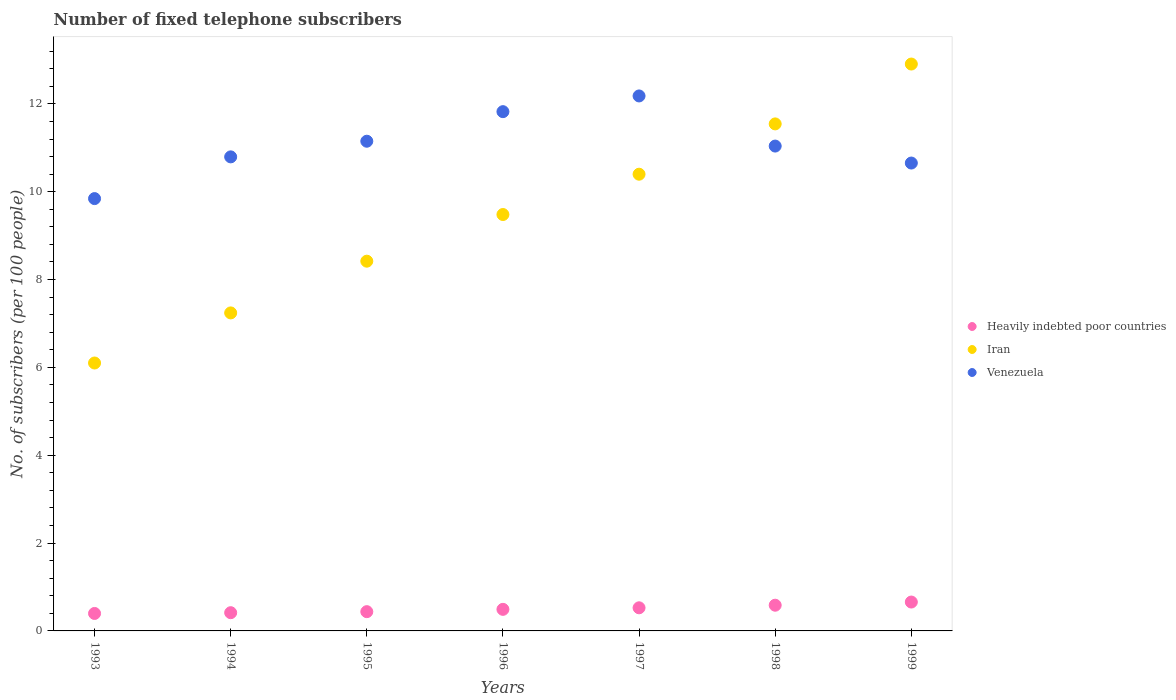Is the number of dotlines equal to the number of legend labels?
Make the answer very short. Yes. What is the number of fixed telephone subscribers in Heavily indebted poor countries in 1995?
Give a very brief answer. 0.44. Across all years, what is the maximum number of fixed telephone subscribers in Heavily indebted poor countries?
Offer a terse response. 0.66. Across all years, what is the minimum number of fixed telephone subscribers in Iran?
Provide a succinct answer. 6.1. In which year was the number of fixed telephone subscribers in Venezuela minimum?
Offer a very short reply. 1993. What is the total number of fixed telephone subscribers in Venezuela in the graph?
Your answer should be compact. 77.48. What is the difference between the number of fixed telephone subscribers in Venezuela in 1994 and that in 1997?
Provide a succinct answer. -1.39. What is the difference between the number of fixed telephone subscribers in Venezuela in 1995 and the number of fixed telephone subscribers in Heavily indebted poor countries in 1999?
Your answer should be compact. 10.49. What is the average number of fixed telephone subscribers in Iran per year?
Provide a short and direct response. 9.44. In the year 1995, what is the difference between the number of fixed telephone subscribers in Iran and number of fixed telephone subscribers in Venezuela?
Your answer should be very brief. -2.73. In how many years, is the number of fixed telephone subscribers in Iran greater than 9.6?
Provide a succinct answer. 3. What is the ratio of the number of fixed telephone subscribers in Venezuela in 1996 to that in 1997?
Provide a short and direct response. 0.97. Is the difference between the number of fixed telephone subscribers in Iran in 1993 and 1996 greater than the difference between the number of fixed telephone subscribers in Venezuela in 1993 and 1996?
Give a very brief answer. No. What is the difference between the highest and the second highest number of fixed telephone subscribers in Heavily indebted poor countries?
Offer a very short reply. 0.07. What is the difference between the highest and the lowest number of fixed telephone subscribers in Heavily indebted poor countries?
Offer a terse response. 0.26. In how many years, is the number of fixed telephone subscribers in Heavily indebted poor countries greater than the average number of fixed telephone subscribers in Heavily indebted poor countries taken over all years?
Offer a very short reply. 3. Is it the case that in every year, the sum of the number of fixed telephone subscribers in Venezuela and number of fixed telephone subscribers in Iran  is greater than the number of fixed telephone subscribers in Heavily indebted poor countries?
Keep it short and to the point. Yes. Does the number of fixed telephone subscribers in Heavily indebted poor countries monotonically increase over the years?
Offer a very short reply. Yes. Is the number of fixed telephone subscribers in Heavily indebted poor countries strictly greater than the number of fixed telephone subscribers in Iran over the years?
Ensure brevity in your answer.  No. Is the number of fixed telephone subscribers in Heavily indebted poor countries strictly less than the number of fixed telephone subscribers in Venezuela over the years?
Keep it short and to the point. Yes. How many dotlines are there?
Make the answer very short. 3. How many years are there in the graph?
Ensure brevity in your answer.  7. Are the values on the major ticks of Y-axis written in scientific E-notation?
Ensure brevity in your answer.  No. How many legend labels are there?
Ensure brevity in your answer.  3. How are the legend labels stacked?
Offer a very short reply. Vertical. What is the title of the graph?
Make the answer very short. Number of fixed telephone subscribers. What is the label or title of the X-axis?
Your answer should be compact. Years. What is the label or title of the Y-axis?
Your answer should be very brief. No. of subscribers (per 100 people). What is the No. of subscribers (per 100 people) of Heavily indebted poor countries in 1993?
Offer a very short reply. 0.4. What is the No. of subscribers (per 100 people) of Iran in 1993?
Your answer should be compact. 6.1. What is the No. of subscribers (per 100 people) in Venezuela in 1993?
Your response must be concise. 9.84. What is the No. of subscribers (per 100 people) in Heavily indebted poor countries in 1994?
Make the answer very short. 0.41. What is the No. of subscribers (per 100 people) in Iran in 1994?
Your answer should be very brief. 7.24. What is the No. of subscribers (per 100 people) of Venezuela in 1994?
Your response must be concise. 10.79. What is the No. of subscribers (per 100 people) of Heavily indebted poor countries in 1995?
Offer a very short reply. 0.44. What is the No. of subscribers (per 100 people) of Iran in 1995?
Ensure brevity in your answer.  8.42. What is the No. of subscribers (per 100 people) in Venezuela in 1995?
Offer a very short reply. 11.15. What is the No. of subscribers (per 100 people) of Heavily indebted poor countries in 1996?
Your response must be concise. 0.49. What is the No. of subscribers (per 100 people) in Iran in 1996?
Make the answer very short. 9.48. What is the No. of subscribers (per 100 people) of Venezuela in 1996?
Provide a short and direct response. 11.82. What is the No. of subscribers (per 100 people) in Heavily indebted poor countries in 1997?
Make the answer very short. 0.53. What is the No. of subscribers (per 100 people) of Iran in 1997?
Give a very brief answer. 10.4. What is the No. of subscribers (per 100 people) of Venezuela in 1997?
Offer a very short reply. 12.18. What is the No. of subscribers (per 100 people) in Heavily indebted poor countries in 1998?
Your response must be concise. 0.59. What is the No. of subscribers (per 100 people) in Iran in 1998?
Provide a short and direct response. 11.54. What is the No. of subscribers (per 100 people) in Venezuela in 1998?
Provide a short and direct response. 11.04. What is the No. of subscribers (per 100 people) of Heavily indebted poor countries in 1999?
Keep it short and to the point. 0.66. What is the No. of subscribers (per 100 people) in Iran in 1999?
Keep it short and to the point. 12.91. What is the No. of subscribers (per 100 people) in Venezuela in 1999?
Provide a short and direct response. 10.65. Across all years, what is the maximum No. of subscribers (per 100 people) of Heavily indebted poor countries?
Give a very brief answer. 0.66. Across all years, what is the maximum No. of subscribers (per 100 people) of Iran?
Your answer should be very brief. 12.91. Across all years, what is the maximum No. of subscribers (per 100 people) of Venezuela?
Give a very brief answer. 12.18. Across all years, what is the minimum No. of subscribers (per 100 people) of Heavily indebted poor countries?
Provide a short and direct response. 0.4. Across all years, what is the minimum No. of subscribers (per 100 people) in Iran?
Offer a terse response. 6.1. Across all years, what is the minimum No. of subscribers (per 100 people) in Venezuela?
Offer a terse response. 9.84. What is the total No. of subscribers (per 100 people) of Heavily indebted poor countries in the graph?
Provide a succinct answer. 3.51. What is the total No. of subscribers (per 100 people) in Iran in the graph?
Offer a very short reply. 66.09. What is the total No. of subscribers (per 100 people) in Venezuela in the graph?
Make the answer very short. 77.48. What is the difference between the No. of subscribers (per 100 people) in Heavily indebted poor countries in 1993 and that in 1994?
Give a very brief answer. -0.02. What is the difference between the No. of subscribers (per 100 people) in Iran in 1993 and that in 1994?
Provide a short and direct response. -1.14. What is the difference between the No. of subscribers (per 100 people) of Venezuela in 1993 and that in 1994?
Provide a short and direct response. -0.95. What is the difference between the No. of subscribers (per 100 people) of Heavily indebted poor countries in 1993 and that in 1995?
Your response must be concise. -0.04. What is the difference between the No. of subscribers (per 100 people) in Iran in 1993 and that in 1995?
Give a very brief answer. -2.32. What is the difference between the No. of subscribers (per 100 people) of Venezuela in 1993 and that in 1995?
Your answer should be compact. -1.31. What is the difference between the No. of subscribers (per 100 people) in Heavily indebted poor countries in 1993 and that in 1996?
Ensure brevity in your answer.  -0.09. What is the difference between the No. of subscribers (per 100 people) of Iran in 1993 and that in 1996?
Your answer should be compact. -3.38. What is the difference between the No. of subscribers (per 100 people) in Venezuela in 1993 and that in 1996?
Your response must be concise. -1.98. What is the difference between the No. of subscribers (per 100 people) of Heavily indebted poor countries in 1993 and that in 1997?
Offer a very short reply. -0.13. What is the difference between the No. of subscribers (per 100 people) in Iran in 1993 and that in 1997?
Make the answer very short. -4.3. What is the difference between the No. of subscribers (per 100 people) in Venezuela in 1993 and that in 1997?
Offer a very short reply. -2.34. What is the difference between the No. of subscribers (per 100 people) in Heavily indebted poor countries in 1993 and that in 1998?
Your answer should be very brief. -0.19. What is the difference between the No. of subscribers (per 100 people) of Iran in 1993 and that in 1998?
Give a very brief answer. -5.44. What is the difference between the No. of subscribers (per 100 people) of Venezuela in 1993 and that in 1998?
Your answer should be compact. -1.2. What is the difference between the No. of subscribers (per 100 people) of Heavily indebted poor countries in 1993 and that in 1999?
Your response must be concise. -0.26. What is the difference between the No. of subscribers (per 100 people) of Iran in 1993 and that in 1999?
Provide a short and direct response. -6.81. What is the difference between the No. of subscribers (per 100 people) of Venezuela in 1993 and that in 1999?
Offer a very short reply. -0.81. What is the difference between the No. of subscribers (per 100 people) of Heavily indebted poor countries in 1994 and that in 1995?
Your response must be concise. -0.02. What is the difference between the No. of subscribers (per 100 people) in Iran in 1994 and that in 1995?
Provide a short and direct response. -1.18. What is the difference between the No. of subscribers (per 100 people) in Venezuela in 1994 and that in 1995?
Provide a short and direct response. -0.36. What is the difference between the No. of subscribers (per 100 people) in Heavily indebted poor countries in 1994 and that in 1996?
Your answer should be compact. -0.08. What is the difference between the No. of subscribers (per 100 people) in Iran in 1994 and that in 1996?
Provide a succinct answer. -2.24. What is the difference between the No. of subscribers (per 100 people) in Venezuela in 1994 and that in 1996?
Provide a short and direct response. -1.03. What is the difference between the No. of subscribers (per 100 people) in Heavily indebted poor countries in 1994 and that in 1997?
Provide a succinct answer. -0.11. What is the difference between the No. of subscribers (per 100 people) in Iran in 1994 and that in 1997?
Ensure brevity in your answer.  -3.16. What is the difference between the No. of subscribers (per 100 people) in Venezuela in 1994 and that in 1997?
Provide a short and direct response. -1.39. What is the difference between the No. of subscribers (per 100 people) in Heavily indebted poor countries in 1994 and that in 1998?
Provide a short and direct response. -0.17. What is the difference between the No. of subscribers (per 100 people) of Iran in 1994 and that in 1998?
Provide a short and direct response. -4.3. What is the difference between the No. of subscribers (per 100 people) of Venezuela in 1994 and that in 1998?
Offer a terse response. -0.25. What is the difference between the No. of subscribers (per 100 people) in Heavily indebted poor countries in 1994 and that in 1999?
Your response must be concise. -0.24. What is the difference between the No. of subscribers (per 100 people) of Iran in 1994 and that in 1999?
Ensure brevity in your answer.  -5.67. What is the difference between the No. of subscribers (per 100 people) in Venezuela in 1994 and that in 1999?
Make the answer very short. 0.14. What is the difference between the No. of subscribers (per 100 people) in Heavily indebted poor countries in 1995 and that in 1996?
Your answer should be very brief. -0.05. What is the difference between the No. of subscribers (per 100 people) of Iran in 1995 and that in 1996?
Your answer should be compact. -1.06. What is the difference between the No. of subscribers (per 100 people) of Venezuela in 1995 and that in 1996?
Give a very brief answer. -0.67. What is the difference between the No. of subscribers (per 100 people) of Heavily indebted poor countries in 1995 and that in 1997?
Provide a short and direct response. -0.09. What is the difference between the No. of subscribers (per 100 people) of Iran in 1995 and that in 1997?
Give a very brief answer. -1.98. What is the difference between the No. of subscribers (per 100 people) of Venezuela in 1995 and that in 1997?
Provide a succinct answer. -1.03. What is the difference between the No. of subscribers (per 100 people) of Heavily indebted poor countries in 1995 and that in 1998?
Make the answer very short. -0.15. What is the difference between the No. of subscribers (per 100 people) of Iran in 1995 and that in 1998?
Your answer should be very brief. -3.13. What is the difference between the No. of subscribers (per 100 people) of Venezuela in 1995 and that in 1998?
Ensure brevity in your answer.  0.11. What is the difference between the No. of subscribers (per 100 people) of Heavily indebted poor countries in 1995 and that in 1999?
Ensure brevity in your answer.  -0.22. What is the difference between the No. of subscribers (per 100 people) in Iran in 1995 and that in 1999?
Offer a terse response. -4.49. What is the difference between the No. of subscribers (per 100 people) in Venezuela in 1995 and that in 1999?
Ensure brevity in your answer.  0.5. What is the difference between the No. of subscribers (per 100 people) in Heavily indebted poor countries in 1996 and that in 1997?
Your response must be concise. -0.04. What is the difference between the No. of subscribers (per 100 people) of Iran in 1996 and that in 1997?
Your answer should be very brief. -0.92. What is the difference between the No. of subscribers (per 100 people) in Venezuela in 1996 and that in 1997?
Offer a very short reply. -0.36. What is the difference between the No. of subscribers (per 100 people) in Heavily indebted poor countries in 1996 and that in 1998?
Offer a terse response. -0.09. What is the difference between the No. of subscribers (per 100 people) of Iran in 1996 and that in 1998?
Make the answer very short. -2.06. What is the difference between the No. of subscribers (per 100 people) of Venezuela in 1996 and that in 1998?
Provide a short and direct response. 0.78. What is the difference between the No. of subscribers (per 100 people) in Heavily indebted poor countries in 1996 and that in 1999?
Make the answer very short. -0.17. What is the difference between the No. of subscribers (per 100 people) in Iran in 1996 and that in 1999?
Your answer should be very brief. -3.43. What is the difference between the No. of subscribers (per 100 people) in Venezuela in 1996 and that in 1999?
Make the answer very short. 1.17. What is the difference between the No. of subscribers (per 100 people) of Heavily indebted poor countries in 1997 and that in 1998?
Give a very brief answer. -0.06. What is the difference between the No. of subscribers (per 100 people) of Iran in 1997 and that in 1998?
Offer a very short reply. -1.15. What is the difference between the No. of subscribers (per 100 people) of Venezuela in 1997 and that in 1998?
Your response must be concise. 1.14. What is the difference between the No. of subscribers (per 100 people) of Heavily indebted poor countries in 1997 and that in 1999?
Give a very brief answer. -0.13. What is the difference between the No. of subscribers (per 100 people) in Iran in 1997 and that in 1999?
Make the answer very short. -2.51. What is the difference between the No. of subscribers (per 100 people) in Venezuela in 1997 and that in 1999?
Keep it short and to the point. 1.53. What is the difference between the No. of subscribers (per 100 people) in Heavily indebted poor countries in 1998 and that in 1999?
Give a very brief answer. -0.07. What is the difference between the No. of subscribers (per 100 people) of Iran in 1998 and that in 1999?
Ensure brevity in your answer.  -1.36. What is the difference between the No. of subscribers (per 100 people) of Venezuela in 1998 and that in 1999?
Ensure brevity in your answer.  0.39. What is the difference between the No. of subscribers (per 100 people) in Heavily indebted poor countries in 1993 and the No. of subscribers (per 100 people) in Iran in 1994?
Make the answer very short. -6.84. What is the difference between the No. of subscribers (per 100 people) in Heavily indebted poor countries in 1993 and the No. of subscribers (per 100 people) in Venezuela in 1994?
Provide a short and direct response. -10.4. What is the difference between the No. of subscribers (per 100 people) of Iran in 1993 and the No. of subscribers (per 100 people) of Venezuela in 1994?
Keep it short and to the point. -4.69. What is the difference between the No. of subscribers (per 100 people) of Heavily indebted poor countries in 1993 and the No. of subscribers (per 100 people) of Iran in 1995?
Your answer should be compact. -8.02. What is the difference between the No. of subscribers (per 100 people) in Heavily indebted poor countries in 1993 and the No. of subscribers (per 100 people) in Venezuela in 1995?
Offer a terse response. -10.75. What is the difference between the No. of subscribers (per 100 people) of Iran in 1993 and the No. of subscribers (per 100 people) of Venezuela in 1995?
Provide a short and direct response. -5.05. What is the difference between the No. of subscribers (per 100 people) of Heavily indebted poor countries in 1993 and the No. of subscribers (per 100 people) of Iran in 1996?
Your response must be concise. -9.08. What is the difference between the No. of subscribers (per 100 people) of Heavily indebted poor countries in 1993 and the No. of subscribers (per 100 people) of Venezuela in 1996?
Provide a succinct answer. -11.43. What is the difference between the No. of subscribers (per 100 people) of Iran in 1993 and the No. of subscribers (per 100 people) of Venezuela in 1996?
Provide a succinct answer. -5.72. What is the difference between the No. of subscribers (per 100 people) of Heavily indebted poor countries in 1993 and the No. of subscribers (per 100 people) of Iran in 1997?
Provide a succinct answer. -10. What is the difference between the No. of subscribers (per 100 people) of Heavily indebted poor countries in 1993 and the No. of subscribers (per 100 people) of Venezuela in 1997?
Your response must be concise. -11.78. What is the difference between the No. of subscribers (per 100 people) of Iran in 1993 and the No. of subscribers (per 100 people) of Venezuela in 1997?
Provide a succinct answer. -6.08. What is the difference between the No. of subscribers (per 100 people) of Heavily indebted poor countries in 1993 and the No. of subscribers (per 100 people) of Iran in 1998?
Ensure brevity in your answer.  -11.15. What is the difference between the No. of subscribers (per 100 people) in Heavily indebted poor countries in 1993 and the No. of subscribers (per 100 people) in Venezuela in 1998?
Ensure brevity in your answer.  -10.64. What is the difference between the No. of subscribers (per 100 people) of Iran in 1993 and the No. of subscribers (per 100 people) of Venezuela in 1998?
Provide a short and direct response. -4.94. What is the difference between the No. of subscribers (per 100 people) of Heavily indebted poor countries in 1993 and the No. of subscribers (per 100 people) of Iran in 1999?
Provide a succinct answer. -12.51. What is the difference between the No. of subscribers (per 100 people) of Heavily indebted poor countries in 1993 and the No. of subscribers (per 100 people) of Venezuela in 1999?
Offer a very short reply. -10.26. What is the difference between the No. of subscribers (per 100 people) of Iran in 1993 and the No. of subscribers (per 100 people) of Venezuela in 1999?
Give a very brief answer. -4.55. What is the difference between the No. of subscribers (per 100 people) in Heavily indebted poor countries in 1994 and the No. of subscribers (per 100 people) in Iran in 1995?
Make the answer very short. -8. What is the difference between the No. of subscribers (per 100 people) of Heavily indebted poor countries in 1994 and the No. of subscribers (per 100 people) of Venezuela in 1995?
Provide a short and direct response. -10.73. What is the difference between the No. of subscribers (per 100 people) of Iran in 1994 and the No. of subscribers (per 100 people) of Venezuela in 1995?
Make the answer very short. -3.91. What is the difference between the No. of subscribers (per 100 people) in Heavily indebted poor countries in 1994 and the No. of subscribers (per 100 people) in Iran in 1996?
Make the answer very short. -9.07. What is the difference between the No. of subscribers (per 100 people) of Heavily indebted poor countries in 1994 and the No. of subscribers (per 100 people) of Venezuela in 1996?
Your answer should be very brief. -11.41. What is the difference between the No. of subscribers (per 100 people) of Iran in 1994 and the No. of subscribers (per 100 people) of Venezuela in 1996?
Provide a short and direct response. -4.58. What is the difference between the No. of subscribers (per 100 people) of Heavily indebted poor countries in 1994 and the No. of subscribers (per 100 people) of Iran in 1997?
Make the answer very short. -9.98. What is the difference between the No. of subscribers (per 100 people) of Heavily indebted poor countries in 1994 and the No. of subscribers (per 100 people) of Venezuela in 1997?
Your answer should be very brief. -11.77. What is the difference between the No. of subscribers (per 100 people) in Iran in 1994 and the No. of subscribers (per 100 people) in Venezuela in 1997?
Your response must be concise. -4.94. What is the difference between the No. of subscribers (per 100 people) in Heavily indebted poor countries in 1994 and the No. of subscribers (per 100 people) in Iran in 1998?
Offer a terse response. -11.13. What is the difference between the No. of subscribers (per 100 people) in Heavily indebted poor countries in 1994 and the No. of subscribers (per 100 people) in Venezuela in 1998?
Keep it short and to the point. -10.62. What is the difference between the No. of subscribers (per 100 people) of Iran in 1994 and the No. of subscribers (per 100 people) of Venezuela in 1998?
Your response must be concise. -3.8. What is the difference between the No. of subscribers (per 100 people) in Heavily indebted poor countries in 1994 and the No. of subscribers (per 100 people) in Iran in 1999?
Give a very brief answer. -12.49. What is the difference between the No. of subscribers (per 100 people) of Heavily indebted poor countries in 1994 and the No. of subscribers (per 100 people) of Venezuela in 1999?
Offer a terse response. -10.24. What is the difference between the No. of subscribers (per 100 people) in Iran in 1994 and the No. of subscribers (per 100 people) in Venezuela in 1999?
Your response must be concise. -3.41. What is the difference between the No. of subscribers (per 100 people) of Heavily indebted poor countries in 1995 and the No. of subscribers (per 100 people) of Iran in 1996?
Offer a terse response. -9.04. What is the difference between the No. of subscribers (per 100 people) of Heavily indebted poor countries in 1995 and the No. of subscribers (per 100 people) of Venezuela in 1996?
Give a very brief answer. -11.38. What is the difference between the No. of subscribers (per 100 people) of Iran in 1995 and the No. of subscribers (per 100 people) of Venezuela in 1996?
Make the answer very short. -3.4. What is the difference between the No. of subscribers (per 100 people) of Heavily indebted poor countries in 1995 and the No. of subscribers (per 100 people) of Iran in 1997?
Your answer should be very brief. -9.96. What is the difference between the No. of subscribers (per 100 people) of Heavily indebted poor countries in 1995 and the No. of subscribers (per 100 people) of Venezuela in 1997?
Give a very brief answer. -11.74. What is the difference between the No. of subscribers (per 100 people) in Iran in 1995 and the No. of subscribers (per 100 people) in Venezuela in 1997?
Provide a short and direct response. -3.76. What is the difference between the No. of subscribers (per 100 people) of Heavily indebted poor countries in 1995 and the No. of subscribers (per 100 people) of Iran in 1998?
Offer a terse response. -11.11. What is the difference between the No. of subscribers (per 100 people) in Heavily indebted poor countries in 1995 and the No. of subscribers (per 100 people) in Venezuela in 1998?
Your answer should be very brief. -10.6. What is the difference between the No. of subscribers (per 100 people) in Iran in 1995 and the No. of subscribers (per 100 people) in Venezuela in 1998?
Ensure brevity in your answer.  -2.62. What is the difference between the No. of subscribers (per 100 people) of Heavily indebted poor countries in 1995 and the No. of subscribers (per 100 people) of Iran in 1999?
Your answer should be very brief. -12.47. What is the difference between the No. of subscribers (per 100 people) in Heavily indebted poor countries in 1995 and the No. of subscribers (per 100 people) in Venezuela in 1999?
Give a very brief answer. -10.21. What is the difference between the No. of subscribers (per 100 people) of Iran in 1995 and the No. of subscribers (per 100 people) of Venezuela in 1999?
Your answer should be compact. -2.23. What is the difference between the No. of subscribers (per 100 people) of Heavily indebted poor countries in 1996 and the No. of subscribers (per 100 people) of Iran in 1997?
Your response must be concise. -9.91. What is the difference between the No. of subscribers (per 100 people) of Heavily indebted poor countries in 1996 and the No. of subscribers (per 100 people) of Venezuela in 1997?
Make the answer very short. -11.69. What is the difference between the No. of subscribers (per 100 people) of Iran in 1996 and the No. of subscribers (per 100 people) of Venezuela in 1997?
Your answer should be very brief. -2.7. What is the difference between the No. of subscribers (per 100 people) in Heavily indebted poor countries in 1996 and the No. of subscribers (per 100 people) in Iran in 1998?
Offer a terse response. -11.05. What is the difference between the No. of subscribers (per 100 people) in Heavily indebted poor countries in 1996 and the No. of subscribers (per 100 people) in Venezuela in 1998?
Ensure brevity in your answer.  -10.55. What is the difference between the No. of subscribers (per 100 people) of Iran in 1996 and the No. of subscribers (per 100 people) of Venezuela in 1998?
Make the answer very short. -1.56. What is the difference between the No. of subscribers (per 100 people) in Heavily indebted poor countries in 1996 and the No. of subscribers (per 100 people) in Iran in 1999?
Provide a succinct answer. -12.42. What is the difference between the No. of subscribers (per 100 people) in Heavily indebted poor countries in 1996 and the No. of subscribers (per 100 people) in Venezuela in 1999?
Offer a very short reply. -10.16. What is the difference between the No. of subscribers (per 100 people) of Iran in 1996 and the No. of subscribers (per 100 people) of Venezuela in 1999?
Keep it short and to the point. -1.17. What is the difference between the No. of subscribers (per 100 people) of Heavily indebted poor countries in 1997 and the No. of subscribers (per 100 people) of Iran in 1998?
Give a very brief answer. -11.02. What is the difference between the No. of subscribers (per 100 people) of Heavily indebted poor countries in 1997 and the No. of subscribers (per 100 people) of Venezuela in 1998?
Your response must be concise. -10.51. What is the difference between the No. of subscribers (per 100 people) of Iran in 1997 and the No. of subscribers (per 100 people) of Venezuela in 1998?
Keep it short and to the point. -0.64. What is the difference between the No. of subscribers (per 100 people) in Heavily indebted poor countries in 1997 and the No. of subscribers (per 100 people) in Iran in 1999?
Your answer should be compact. -12.38. What is the difference between the No. of subscribers (per 100 people) in Heavily indebted poor countries in 1997 and the No. of subscribers (per 100 people) in Venezuela in 1999?
Your answer should be very brief. -10.13. What is the difference between the No. of subscribers (per 100 people) of Iran in 1997 and the No. of subscribers (per 100 people) of Venezuela in 1999?
Offer a very short reply. -0.25. What is the difference between the No. of subscribers (per 100 people) of Heavily indebted poor countries in 1998 and the No. of subscribers (per 100 people) of Iran in 1999?
Your answer should be very brief. -12.32. What is the difference between the No. of subscribers (per 100 people) of Heavily indebted poor countries in 1998 and the No. of subscribers (per 100 people) of Venezuela in 1999?
Ensure brevity in your answer.  -10.07. What is the difference between the No. of subscribers (per 100 people) in Iran in 1998 and the No. of subscribers (per 100 people) in Venezuela in 1999?
Offer a terse response. 0.89. What is the average No. of subscribers (per 100 people) in Heavily indebted poor countries per year?
Offer a very short reply. 0.5. What is the average No. of subscribers (per 100 people) of Iran per year?
Give a very brief answer. 9.44. What is the average No. of subscribers (per 100 people) in Venezuela per year?
Provide a short and direct response. 11.07. In the year 1993, what is the difference between the No. of subscribers (per 100 people) of Heavily indebted poor countries and No. of subscribers (per 100 people) of Iran?
Offer a very short reply. -5.7. In the year 1993, what is the difference between the No. of subscribers (per 100 people) in Heavily indebted poor countries and No. of subscribers (per 100 people) in Venezuela?
Give a very brief answer. -9.45. In the year 1993, what is the difference between the No. of subscribers (per 100 people) in Iran and No. of subscribers (per 100 people) in Venezuela?
Provide a succinct answer. -3.74. In the year 1994, what is the difference between the No. of subscribers (per 100 people) in Heavily indebted poor countries and No. of subscribers (per 100 people) in Iran?
Your response must be concise. -6.83. In the year 1994, what is the difference between the No. of subscribers (per 100 people) of Heavily indebted poor countries and No. of subscribers (per 100 people) of Venezuela?
Give a very brief answer. -10.38. In the year 1994, what is the difference between the No. of subscribers (per 100 people) in Iran and No. of subscribers (per 100 people) in Venezuela?
Offer a terse response. -3.55. In the year 1995, what is the difference between the No. of subscribers (per 100 people) of Heavily indebted poor countries and No. of subscribers (per 100 people) of Iran?
Give a very brief answer. -7.98. In the year 1995, what is the difference between the No. of subscribers (per 100 people) in Heavily indebted poor countries and No. of subscribers (per 100 people) in Venezuela?
Your response must be concise. -10.71. In the year 1995, what is the difference between the No. of subscribers (per 100 people) of Iran and No. of subscribers (per 100 people) of Venezuela?
Offer a terse response. -2.73. In the year 1996, what is the difference between the No. of subscribers (per 100 people) in Heavily indebted poor countries and No. of subscribers (per 100 people) in Iran?
Give a very brief answer. -8.99. In the year 1996, what is the difference between the No. of subscribers (per 100 people) in Heavily indebted poor countries and No. of subscribers (per 100 people) in Venezuela?
Offer a very short reply. -11.33. In the year 1996, what is the difference between the No. of subscribers (per 100 people) of Iran and No. of subscribers (per 100 people) of Venezuela?
Offer a very short reply. -2.34. In the year 1997, what is the difference between the No. of subscribers (per 100 people) in Heavily indebted poor countries and No. of subscribers (per 100 people) in Iran?
Offer a very short reply. -9.87. In the year 1997, what is the difference between the No. of subscribers (per 100 people) of Heavily indebted poor countries and No. of subscribers (per 100 people) of Venezuela?
Your answer should be compact. -11.65. In the year 1997, what is the difference between the No. of subscribers (per 100 people) of Iran and No. of subscribers (per 100 people) of Venezuela?
Your answer should be compact. -1.78. In the year 1998, what is the difference between the No. of subscribers (per 100 people) in Heavily indebted poor countries and No. of subscribers (per 100 people) in Iran?
Your answer should be very brief. -10.96. In the year 1998, what is the difference between the No. of subscribers (per 100 people) of Heavily indebted poor countries and No. of subscribers (per 100 people) of Venezuela?
Offer a very short reply. -10.45. In the year 1998, what is the difference between the No. of subscribers (per 100 people) in Iran and No. of subscribers (per 100 people) in Venezuela?
Ensure brevity in your answer.  0.5. In the year 1999, what is the difference between the No. of subscribers (per 100 people) of Heavily indebted poor countries and No. of subscribers (per 100 people) of Iran?
Your answer should be very brief. -12.25. In the year 1999, what is the difference between the No. of subscribers (per 100 people) of Heavily indebted poor countries and No. of subscribers (per 100 people) of Venezuela?
Keep it short and to the point. -10. In the year 1999, what is the difference between the No. of subscribers (per 100 people) of Iran and No. of subscribers (per 100 people) of Venezuela?
Your response must be concise. 2.25. What is the ratio of the No. of subscribers (per 100 people) of Iran in 1993 to that in 1994?
Offer a very short reply. 0.84. What is the ratio of the No. of subscribers (per 100 people) of Venezuela in 1993 to that in 1994?
Offer a terse response. 0.91. What is the ratio of the No. of subscribers (per 100 people) of Heavily indebted poor countries in 1993 to that in 1995?
Provide a succinct answer. 0.91. What is the ratio of the No. of subscribers (per 100 people) in Iran in 1993 to that in 1995?
Provide a succinct answer. 0.72. What is the ratio of the No. of subscribers (per 100 people) of Venezuela in 1993 to that in 1995?
Your response must be concise. 0.88. What is the ratio of the No. of subscribers (per 100 people) in Heavily indebted poor countries in 1993 to that in 1996?
Provide a succinct answer. 0.81. What is the ratio of the No. of subscribers (per 100 people) of Iran in 1993 to that in 1996?
Offer a very short reply. 0.64. What is the ratio of the No. of subscribers (per 100 people) in Venezuela in 1993 to that in 1996?
Your response must be concise. 0.83. What is the ratio of the No. of subscribers (per 100 people) of Heavily indebted poor countries in 1993 to that in 1997?
Give a very brief answer. 0.76. What is the ratio of the No. of subscribers (per 100 people) in Iran in 1993 to that in 1997?
Ensure brevity in your answer.  0.59. What is the ratio of the No. of subscribers (per 100 people) in Venezuela in 1993 to that in 1997?
Your response must be concise. 0.81. What is the ratio of the No. of subscribers (per 100 people) of Heavily indebted poor countries in 1993 to that in 1998?
Provide a succinct answer. 0.68. What is the ratio of the No. of subscribers (per 100 people) of Iran in 1993 to that in 1998?
Ensure brevity in your answer.  0.53. What is the ratio of the No. of subscribers (per 100 people) of Venezuela in 1993 to that in 1998?
Provide a short and direct response. 0.89. What is the ratio of the No. of subscribers (per 100 people) in Heavily indebted poor countries in 1993 to that in 1999?
Offer a very short reply. 0.6. What is the ratio of the No. of subscribers (per 100 people) of Iran in 1993 to that in 1999?
Offer a very short reply. 0.47. What is the ratio of the No. of subscribers (per 100 people) in Venezuela in 1993 to that in 1999?
Ensure brevity in your answer.  0.92. What is the ratio of the No. of subscribers (per 100 people) of Heavily indebted poor countries in 1994 to that in 1995?
Give a very brief answer. 0.95. What is the ratio of the No. of subscribers (per 100 people) of Iran in 1994 to that in 1995?
Keep it short and to the point. 0.86. What is the ratio of the No. of subscribers (per 100 people) in Heavily indebted poor countries in 1994 to that in 1996?
Offer a very short reply. 0.84. What is the ratio of the No. of subscribers (per 100 people) in Iran in 1994 to that in 1996?
Ensure brevity in your answer.  0.76. What is the ratio of the No. of subscribers (per 100 people) in Venezuela in 1994 to that in 1996?
Provide a short and direct response. 0.91. What is the ratio of the No. of subscribers (per 100 people) of Heavily indebted poor countries in 1994 to that in 1997?
Give a very brief answer. 0.79. What is the ratio of the No. of subscribers (per 100 people) in Iran in 1994 to that in 1997?
Keep it short and to the point. 0.7. What is the ratio of the No. of subscribers (per 100 people) in Venezuela in 1994 to that in 1997?
Provide a succinct answer. 0.89. What is the ratio of the No. of subscribers (per 100 people) in Heavily indebted poor countries in 1994 to that in 1998?
Provide a short and direct response. 0.71. What is the ratio of the No. of subscribers (per 100 people) in Iran in 1994 to that in 1998?
Offer a very short reply. 0.63. What is the ratio of the No. of subscribers (per 100 people) in Venezuela in 1994 to that in 1998?
Keep it short and to the point. 0.98. What is the ratio of the No. of subscribers (per 100 people) of Heavily indebted poor countries in 1994 to that in 1999?
Your answer should be very brief. 0.63. What is the ratio of the No. of subscribers (per 100 people) of Iran in 1994 to that in 1999?
Offer a terse response. 0.56. What is the ratio of the No. of subscribers (per 100 people) in Venezuela in 1994 to that in 1999?
Ensure brevity in your answer.  1.01. What is the ratio of the No. of subscribers (per 100 people) in Heavily indebted poor countries in 1995 to that in 1996?
Provide a short and direct response. 0.89. What is the ratio of the No. of subscribers (per 100 people) in Iran in 1995 to that in 1996?
Make the answer very short. 0.89. What is the ratio of the No. of subscribers (per 100 people) of Venezuela in 1995 to that in 1996?
Your response must be concise. 0.94. What is the ratio of the No. of subscribers (per 100 people) in Heavily indebted poor countries in 1995 to that in 1997?
Your answer should be very brief. 0.83. What is the ratio of the No. of subscribers (per 100 people) of Iran in 1995 to that in 1997?
Keep it short and to the point. 0.81. What is the ratio of the No. of subscribers (per 100 people) in Venezuela in 1995 to that in 1997?
Provide a succinct answer. 0.92. What is the ratio of the No. of subscribers (per 100 people) of Heavily indebted poor countries in 1995 to that in 1998?
Offer a very short reply. 0.75. What is the ratio of the No. of subscribers (per 100 people) in Iran in 1995 to that in 1998?
Your answer should be compact. 0.73. What is the ratio of the No. of subscribers (per 100 people) of Heavily indebted poor countries in 1995 to that in 1999?
Provide a succinct answer. 0.67. What is the ratio of the No. of subscribers (per 100 people) in Iran in 1995 to that in 1999?
Provide a succinct answer. 0.65. What is the ratio of the No. of subscribers (per 100 people) of Venezuela in 1995 to that in 1999?
Provide a short and direct response. 1.05. What is the ratio of the No. of subscribers (per 100 people) of Heavily indebted poor countries in 1996 to that in 1997?
Make the answer very short. 0.93. What is the ratio of the No. of subscribers (per 100 people) of Iran in 1996 to that in 1997?
Give a very brief answer. 0.91. What is the ratio of the No. of subscribers (per 100 people) in Venezuela in 1996 to that in 1997?
Keep it short and to the point. 0.97. What is the ratio of the No. of subscribers (per 100 people) of Heavily indebted poor countries in 1996 to that in 1998?
Provide a short and direct response. 0.84. What is the ratio of the No. of subscribers (per 100 people) of Iran in 1996 to that in 1998?
Offer a terse response. 0.82. What is the ratio of the No. of subscribers (per 100 people) of Venezuela in 1996 to that in 1998?
Your answer should be very brief. 1.07. What is the ratio of the No. of subscribers (per 100 people) of Heavily indebted poor countries in 1996 to that in 1999?
Your response must be concise. 0.75. What is the ratio of the No. of subscribers (per 100 people) in Iran in 1996 to that in 1999?
Keep it short and to the point. 0.73. What is the ratio of the No. of subscribers (per 100 people) of Venezuela in 1996 to that in 1999?
Make the answer very short. 1.11. What is the ratio of the No. of subscribers (per 100 people) of Heavily indebted poor countries in 1997 to that in 1998?
Keep it short and to the point. 0.9. What is the ratio of the No. of subscribers (per 100 people) of Iran in 1997 to that in 1998?
Keep it short and to the point. 0.9. What is the ratio of the No. of subscribers (per 100 people) of Venezuela in 1997 to that in 1998?
Ensure brevity in your answer.  1.1. What is the ratio of the No. of subscribers (per 100 people) in Heavily indebted poor countries in 1997 to that in 1999?
Offer a terse response. 0.8. What is the ratio of the No. of subscribers (per 100 people) in Iran in 1997 to that in 1999?
Ensure brevity in your answer.  0.81. What is the ratio of the No. of subscribers (per 100 people) of Venezuela in 1997 to that in 1999?
Your answer should be very brief. 1.14. What is the ratio of the No. of subscribers (per 100 people) in Heavily indebted poor countries in 1998 to that in 1999?
Offer a very short reply. 0.89. What is the ratio of the No. of subscribers (per 100 people) in Iran in 1998 to that in 1999?
Provide a short and direct response. 0.89. What is the ratio of the No. of subscribers (per 100 people) in Venezuela in 1998 to that in 1999?
Provide a short and direct response. 1.04. What is the difference between the highest and the second highest No. of subscribers (per 100 people) of Heavily indebted poor countries?
Your response must be concise. 0.07. What is the difference between the highest and the second highest No. of subscribers (per 100 people) in Iran?
Ensure brevity in your answer.  1.36. What is the difference between the highest and the second highest No. of subscribers (per 100 people) in Venezuela?
Offer a terse response. 0.36. What is the difference between the highest and the lowest No. of subscribers (per 100 people) of Heavily indebted poor countries?
Ensure brevity in your answer.  0.26. What is the difference between the highest and the lowest No. of subscribers (per 100 people) in Iran?
Ensure brevity in your answer.  6.81. What is the difference between the highest and the lowest No. of subscribers (per 100 people) in Venezuela?
Your answer should be very brief. 2.34. 